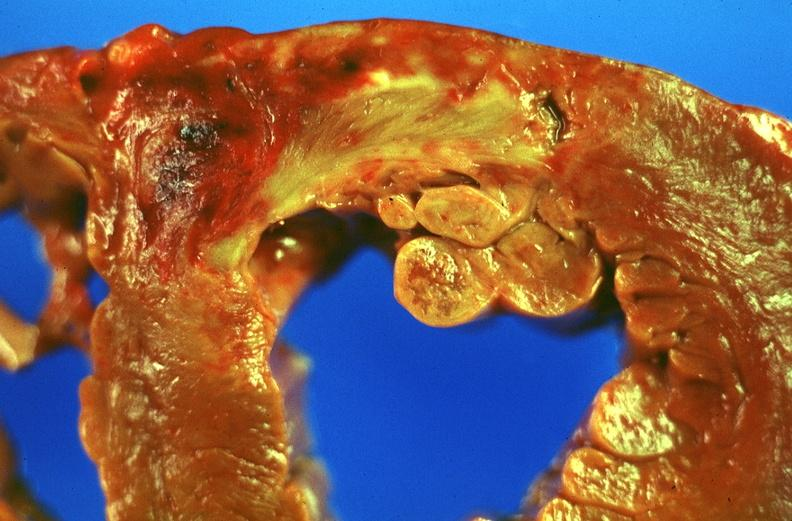does lateral view show acute myocardial infarction?
Answer the question using a single word or phrase. No 